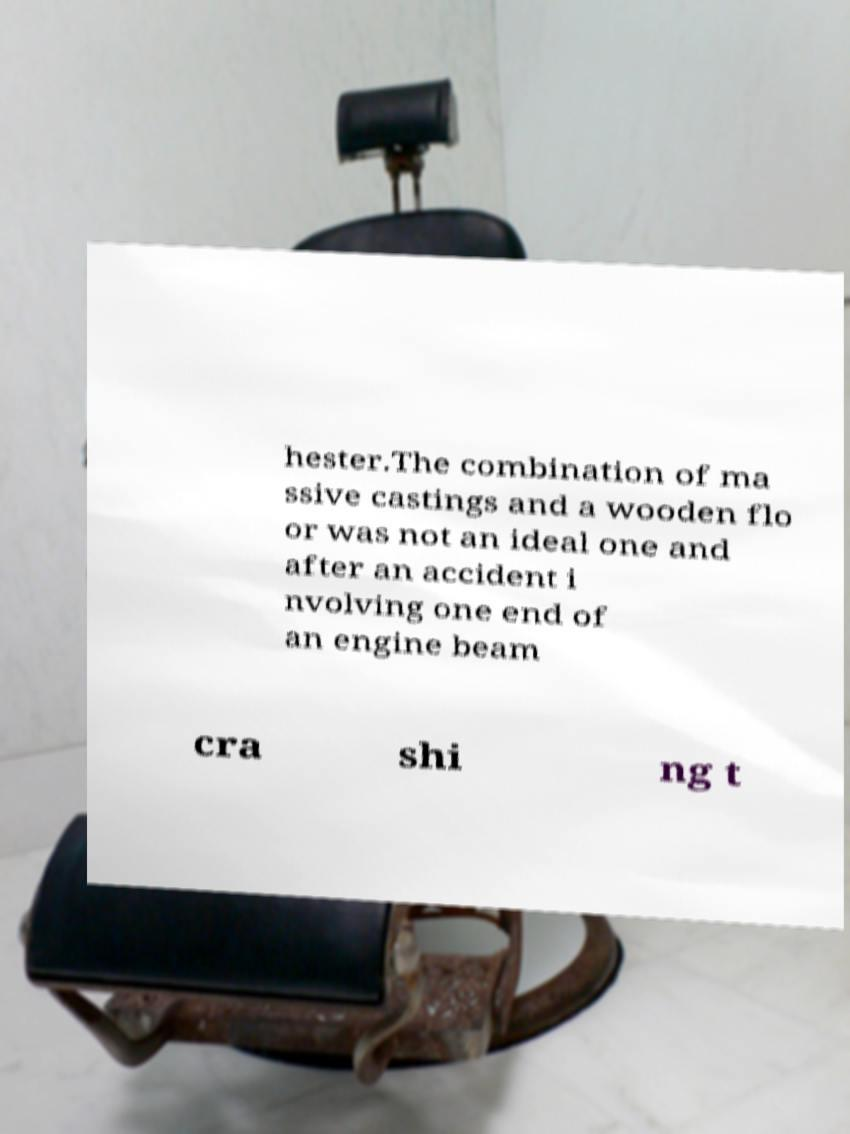Please read and relay the text visible in this image. What does it say? hester.The combination of ma ssive castings and a wooden flo or was not an ideal one and after an accident i nvolving one end of an engine beam cra shi ng t 